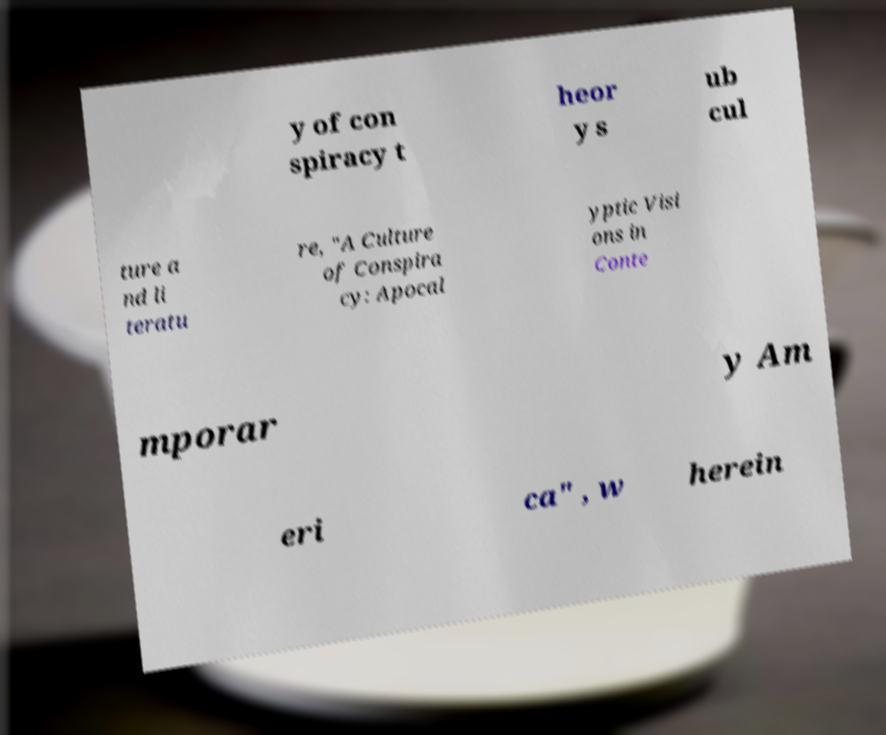What messages or text are displayed in this image? I need them in a readable, typed format. y of con spiracy t heor y s ub cul ture a nd li teratu re, "A Culture of Conspira cy: Apocal yptic Visi ons in Conte mporar y Am eri ca" , w herein 